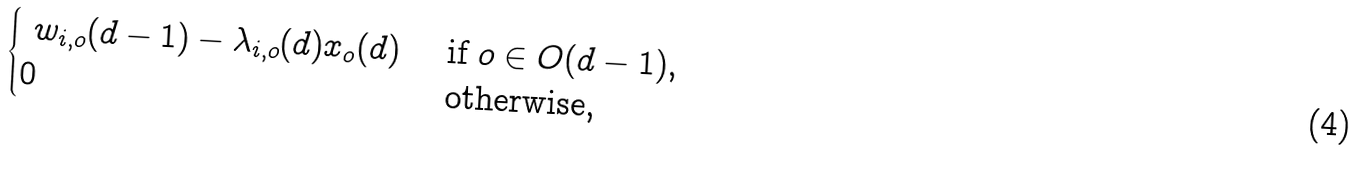<formula> <loc_0><loc_0><loc_500><loc_500>\begin{cases} \ w _ { i , o } ( d - 1 ) - \lambda _ { i , o } ( d ) x _ { o } ( d ) & \text { if } o \in O ( d - 1 ) , \\ 0 & \text { otherwise,} \end{cases}</formula> 